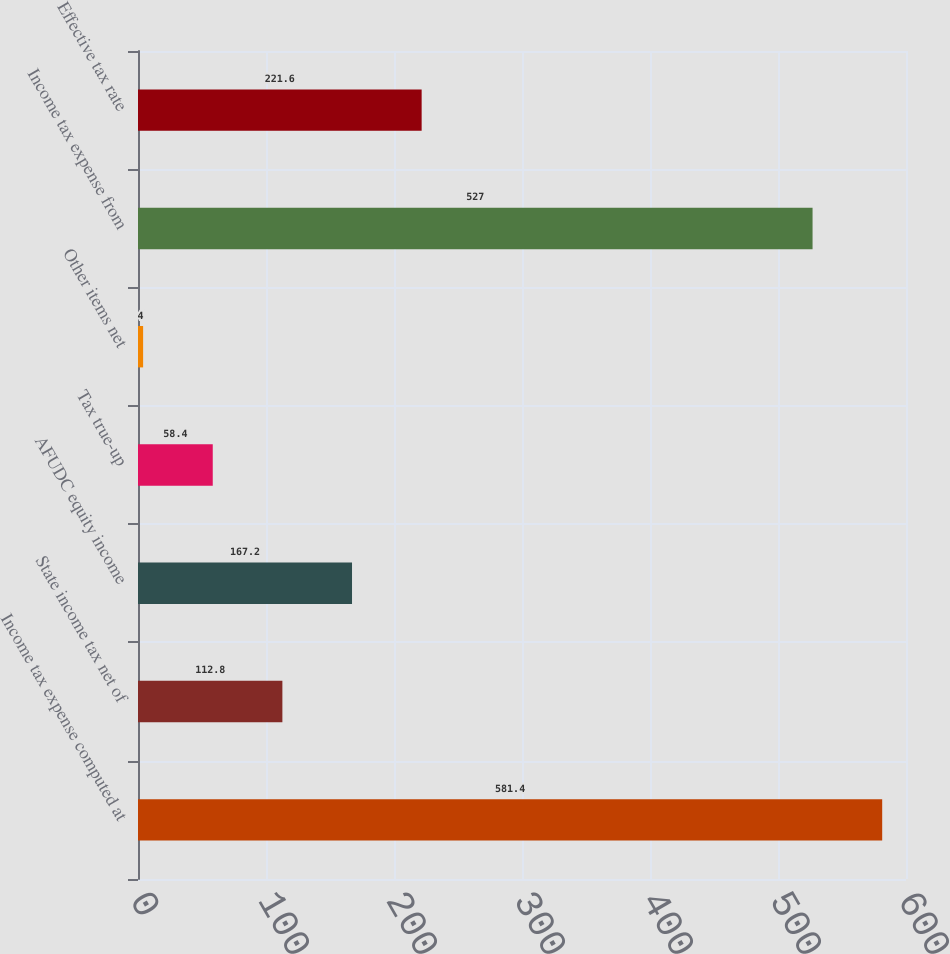<chart> <loc_0><loc_0><loc_500><loc_500><bar_chart><fcel>Income tax expense computed at<fcel>State income tax net of<fcel>AFUDC equity income<fcel>Tax true-up<fcel>Other items net<fcel>Income tax expense from<fcel>Effective tax rate<nl><fcel>581.4<fcel>112.8<fcel>167.2<fcel>58.4<fcel>4<fcel>527<fcel>221.6<nl></chart> 